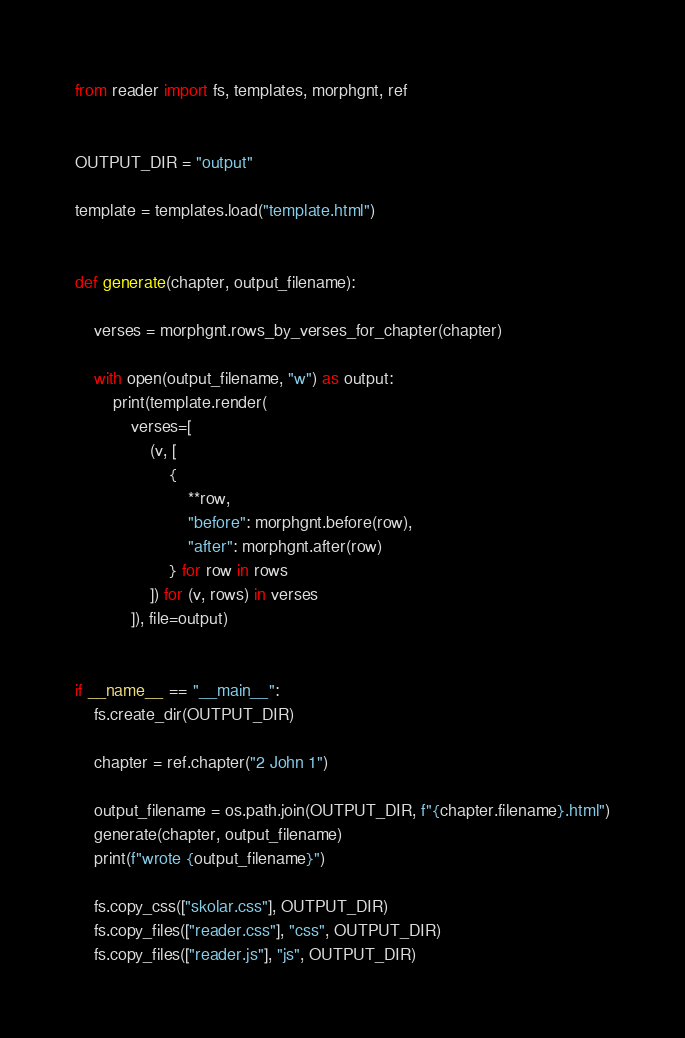Convert code to text. <code><loc_0><loc_0><loc_500><loc_500><_Python_>
from reader import fs, templates, morphgnt, ref


OUTPUT_DIR = "output"

template = templates.load("template.html")


def generate(chapter, output_filename):

    verses = morphgnt.rows_by_verses_for_chapter(chapter)

    with open(output_filename, "w") as output:
        print(template.render(
            verses=[
                (v, [
                    {
                        **row,
                        "before": morphgnt.before(row),
                        "after": morphgnt.after(row)
                    } for row in rows
                ]) for (v, rows) in verses
            ]), file=output)


if __name__ == "__main__":
    fs.create_dir(OUTPUT_DIR)

    chapter = ref.chapter("2 John 1")

    output_filename = os.path.join(OUTPUT_DIR, f"{chapter.filename}.html")
    generate(chapter, output_filename)
    print(f"wrote {output_filename}")

    fs.copy_css(["skolar.css"], OUTPUT_DIR)
    fs.copy_files(["reader.css"], "css", OUTPUT_DIR)
    fs.copy_files(["reader.js"], "js", OUTPUT_DIR)
</code> 